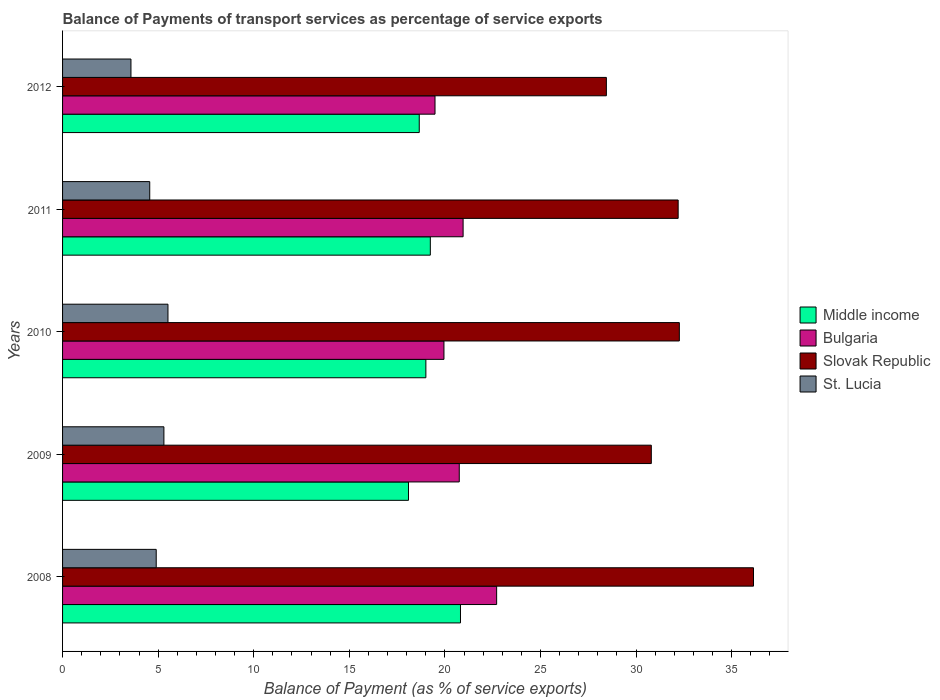How many different coloured bars are there?
Provide a short and direct response. 4. How many bars are there on the 2nd tick from the bottom?
Give a very brief answer. 4. What is the label of the 3rd group of bars from the top?
Your answer should be compact. 2010. What is the balance of payments of transport services in St. Lucia in 2012?
Provide a succinct answer. 3.58. Across all years, what is the maximum balance of payments of transport services in Slovak Republic?
Keep it short and to the point. 36.14. Across all years, what is the minimum balance of payments of transport services in Slovak Republic?
Your response must be concise. 28.45. What is the total balance of payments of transport services in Slovak Republic in the graph?
Your answer should be very brief. 159.86. What is the difference between the balance of payments of transport services in Bulgaria in 2010 and that in 2012?
Make the answer very short. 0.47. What is the difference between the balance of payments of transport services in St. Lucia in 2009 and the balance of payments of transport services in Bulgaria in 2012?
Offer a terse response. -14.18. What is the average balance of payments of transport services in Middle income per year?
Offer a terse response. 19.16. In the year 2010, what is the difference between the balance of payments of transport services in Bulgaria and balance of payments of transport services in Slovak Republic?
Your answer should be very brief. -12.31. In how many years, is the balance of payments of transport services in Middle income greater than 16 %?
Give a very brief answer. 5. What is the ratio of the balance of payments of transport services in Bulgaria in 2010 to that in 2012?
Keep it short and to the point. 1.02. Is the difference between the balance of payments of transport services in Bulgaria in 2009 and 2011 greater than the difference between the balance of payments of transport services in Slovak Republic in 2009 and 2011?
Keep it short and to the point. Yes. What is the difference between the highest and the second highest balance of payments of transport services in Middle income?
Keep it short and to the point. 1.58. What is the difference between the highest and the lowest balance of payments of transport services in Bulgaria?
Offer a terse response. 3.22. In how many years, is the balance of payments of transport services in St. Lucia greater than the average balance of payments of transport services in St. Lucia taken over all years?
Ensure brevity in your answer.  3. What does the 2nd bar from the top in 2012 represents?
Make the answer very short. Slovak Republic. What does the 1st bar from the bottom in 2008 represents?
Give a very brief answer. Middle income. Is it the case that in every year, the sum of the balance of payments of transport services in Bulgaria and balance of payments of transport services in St. Lucia is greater than the balance of payments of transport services in Middle income?
Offer a very short reply. Yes. How many bars are there?
Offer a terse response. 20. Are all the bars in the graph horizontal?
Give a very brief answer. Yes. How many years are there in the graph?
Your answer should be compact. 5. Are the values on the major ticks of X-axis written in scientific E-notation?
Keep it short and to the point. No. Does the graph contain grids?
Make the answer very short. No. Where does the legend appear in the graph?
Your answer should be compact. Center right. How many legend labels are there?
Offer a terse response. 4. What is the title of the graph?
Provide a short and direct response. Balance of Payments of transport services as percentage of service exports. Does "Estonia" appear as one of the legend labels in the graph?
Provide a succinct answer. No. What is the label or title of the X-axis?
Provide a succinct answer. Balance of Payment (as % of service exports). What is the label or title of the Y-axis?
Offer a terse response. Years. What is the Balance of Payment (as % of service exports) in Middle income in 2008?
Provide a short and direct response. 20.82. What is the Balance of Payment (as % of service exports) of Bulgaria in 2008?
Your response must be concise. 22.71. What is the Balance of Payment (as % of service exports) in Slovak Republic in 2008?
Your answer should be very brief. 36.14. What is the Balance of Payment (as % of service exports) in St. Lucia in 2008?
Keep it short and to the point. 4.9. What is the Balance of Payment (as % of service exports) of Middle income in 2009?
Ensure brevity in your answer.  18.1. What is the Balance of Payment (as % of service exports) in Bulgaria in 2009?
Offer a very short reply. 20.75. What is the Balance of Payment (as % of service exports) in Slovak Republic in 2009?
Ensure brevity in your answer.  30.8. What is the Balance of Payment (as % of service exports) in St. Lucia in 2009?
Your answer should be very brief. 5.3. What is the Balance of Payment (as % of service exports) in Middle income in 2010?
Your answer should be compact. 19.01. What is the Balance of Payment (as % of service exports) of Bulgaria in 2010?
Provide a short and direct response. 19.95. What is the Balance of Payment (as % of service exports) of Slovak Republic in 2010?
Provide a succinct answer. 32.27. What is the Balance of Payment (as % of service exports) of St. Lucia in 2010?
Offer a very short reply. 5.51. What is the Balance of Payment (as % of service exports) in Middle income in 2011?
Your response must be concise. 19.24. What is the Balance of Payment (as % of service exports) in Bulgaria in 2011?
Give a very brief answer. 20.95. What is the Balance of Payment (as % of service exports) of Slovak Republic in 2011?
Make the answer very short. 32.2. What is the Balance of Payment (as % of service exports) of St. Lucia in 2011?
Provide a short and direct response. 4.56. What is the Balance of Payment (as % of service exports) in Middle income in 2012?
Offer a very short reply. 18.66. What is the Balance of Payment (as % of service exports) of Bulgaria in 2012?
Keep it short and to the point. 19.48. What is the Balance of Payment (as % of service exports) of Slovak Republic in 2012?
Offer a very short reply. 28.45. What is the Balance of Payment (as % of service exports) in St. Lucia in 2012?
Your answer should be compact. 3.58. Across all years, what is the maximum Balance of Payment (as % of service exports) of Middle income?
Ensure brevity in your answer.  20.82. Across all years, what is the maximum Balance of Payment (as % of service exports) of Bulgaria?
Provide a succinct answer. 22.71. Across all years, what is the maximum Balance of Payment (as % of service exports) of Slovak Republic?
Ensure brevity in your answer.  36.14. Across all years, what is the maximum Balance of Payment (as % of service exports) in St. Lucia?
Offer a terse response. 5.51. Across all years, what is the minimum Balance of Payment (as % of service exports) of Middle income?
Your response must be concise. 18.1. Across all years, what is the minimum Balance of Payment (as % of service exports) of Bulgaria?
Offer a terse response. 19.48. Across all years, what is the minimum Balance of Payment (as % of service exports) of Slovak Republic?
Your answer should be compact. 28.45. Across all years, what is the minimum Balance of Payment (as % of service exports) in St. Lucia?
Provide a succinct answer. 3.58. What is the total Balance of Payment (as % of service exports) of Middle income in the graph?
Provide a succinct answer. 95.81. What is the total Balance of Payment (as % of service exports) in Bulgaria in the graph?
Your response must be concise. 103.85. What is the total Balance of Payment (as % of service exports) in Slovak Republic in the graph?
Your answer should be very brief. 159.86. What is the total Balance of Payment (as % of service exports) in St. Lucia in the graph?
Offer a terse response. 23.85. What is the difference between the Balance of Payment (as % of service exports) of Middle income in 2008 and that in 2009?
Give a very brief answer. 2.72. What is the difference between the Balance of Payment (as % of service exports) of Bulgaria in 2008 and that in 2009?
Your response must be concise. 1.96. What is the difference between the Balance of Payment (as % of service exports) of Slovak Republic in 2008 and that in 2009?
Your answer should be compact. 5.35. What is the difference between the Balance of Payment (as % of service exports) of St. Lucia in 2008 and that in 2009?
Ensure brevity in your answer.  -0.4. What is the difference between the Balance of Payment (as % of service exports) in Middle income in 2008 and that in 2010?
Your answer should be very brief. 1.81. What is the difference between the Balance of Payment (as % of service exports) in Bulgaria in 2008 and that in 2010?
Keep it short and to the point. 2.76. What is the difference between the Balance of Payment (as % of service exports) of Slovak Republic in 2008 and that in 2010?
Give a very brief answer. 3.88. What is the difference between the Balance of Payment (as % of service exports) of St. Lucia in 2008 and that in 2010?
Provide a succinct answer. -0.61. What is the difference between the Balance of Payment (as % of service exports) of Middle income in 2008 and that in 2011?
Provide a succinct answer. 1.58. What is the difference between the Balance of Payment (as % of service exports) of Bulgaria in 2008 and that in 2011?
Provide a short and direct response. 1.75. What is the difference between the Balance of Payment (as % of service exports) of Slovak Republic in 2008 and that in 2011?
Make the answer very short. 3.94. What is the difference between the Balance of Payment (as % of service exports) in St. Lucia in 2008 and that in 2011?
Offer a terse response. 0.34. What is the difference between the Balance of Payment (as % of service exports) of Middle income in 2008 and that in 2012?
Provide a short and direct response. 2.16. What is the difference between the Balance of Payment (as % of service exports) of Bulgaria in 2008 and that in 2012?
Your answer should be very brief. 3.22. What is the difference between the Balance of Payment (as % of service exports) in Slovak Republic in 2008 and that in 2012?
Give a very brief answer. 7.7. What is the difference between the Balance of Payment (as % of service exports) in St. Lucia in 2008 and that in 2012?
Your response must be concise. 1.32. What is the difference between the Balance of Payment (as % of service exports) of Middle income in 2009 and that in 2010?
Offer a terse response. -0.91. What is the difference between the Balance of Payment (as % of service exports) in Bulgaria in 2009 and that in 2010?
Your answer should be compact. 0.8. What is the difference between the Balance of Payment (as % of service exports) in Slovak Republic in 2009 and that in 2010?
Provide a succinct answer. -1.47. What is the difference between the Balance of Payment (as % of service exports) of St. Lucia in 2009 and that in 2010?
Keep it short and to the point. -0.21. What is the difference between the Balance of Payment (as % of service exports) of Middle income in 2009 and that in 2011?
Offer a terse response. -1.14. What is the difference between the Balance of Payment (as % of service exports) in Bulgaria in 2009 and that in 2011?
Offer a terse response. -0.2. What is the difference between the Balance of Payment (as % of service exports) of Slovak Republic in 2009 and that in 2011?
Offer a terse response. -1.4. What is the difference between the Balance of Payment (as % of service exports) of St. Lucia in 2009 and that in 2011?
Keep it short and to the point. 0.74. What is the difference between the Balance of Payment (as % of service exports) in Middle income in 2009 and that in 2012?
Offer a terse response. -0.56. What is the difference between the Balance of Payment (as % of service exports) in Bulgaria in 2009 and that in 2012?
Provide a succinct answer. 1.27. What is the difference between the Balance of Payment (as % of service exports) in Slovak Republic in 2009 and that in 2012?
Offer a very short reply. 2.35. What is the difference between the Balance of Payment (as % of service exports) in St. Lucia in 2009 and that in 2012?
Make the answer very short. 1.72. What is the difference between the Balance of Payment (as % of service exports) in Middle income in 2010 and that in 2011?
Make the answer very short. -0.23. What is the difference between the Balance of Payment (as % of service exports) in Bulgaria in 2010 and that in 2011?
Ensure brevity in your answer.  -1. What is the difference between the Balance of Payment (as % of service exports) of Slovak Republic in 2010 and that in 2011?
Ensure brevity in your answer.  0.06. What is the difference between the Balance of Payment (as % of service exports) in St. Lucia in 2010 and that in 2011?
Offer a terse response. 0.95. What is the difference between the Balance of Payment (as % of service exports) of Middle income in 2010 and that in 2012?
Offer a terse response. 0.35. What is the difference between the Balance of Payment (as % of service exports) of Bulgaria in 2010 and that in 2012?
Give a very brief answer. 0.47. What is the difference between the Balance of Payment (as % of service exports) in Slovak Republic in 2010 and that in 2012?
Keep it short and to the point. 3.82. What is the difference between the Balance of Payment (as % of service exports) of St. Lucia in 2010 and that in 2012?
Your answer should be very brief. 1.94. What is the difference between the Balance of Payment (as % of service exports) in Middle income in 2011 and that in 2012?
Provide a succinct answer. 0.58. What is the difference between the Balance of Payment (as % of service exports) in Bulgaria in 2011 and that in 2012?
Offer a very short reply. 1.47. What is the difference between the Balance of Payment (as % of service exports) of Slovak Republic in 2011 and that in 2012?
Offer a terse response. 3.76. What is the difference between the Balance of Payment (as % of service exports) in St. Lucia in 2011 and that in 2012?
Your answer should be very brief. 0.98. What is the difference between the Balance of Payment (as % of service exports) of Middle income in 2008 and the Balance of Payment (as % of service exports) of Bulgaria in 2009?
Keep it short and to the point. 0.06. What is the difference between the Balance of Payment (as % of service exports) in Middle income in 2008 and the Balance of Payment (as % of service exports) in Slovak Republic in 2009?
Your response must be concise. -9.98. What is the difference between the Balance of Payment (as % of service exports) of Middle income in 2008 and the Balance of Payment (as % of service exports) of St. Lucia in 2009?
Offer a very short reply. 15.51. What is the difference between the Balance of Payment (as % of service exports) in Bulgaria in 2008 and the Balance of Payment (as % of service exports) in Slovak Republic in 2009?
Offer a very short reply. -8.09. What is the difference between the Balance of Payment (as % of service exports) of Bulgaria in 2008 and the Balance of Payment (as % of service exports) of St. Lucia in 2009?
Your response must be concise. 17.41. What is the difference between the Balance of Payment (as % of service exports) in Slovak Republic in 2008 and the Balance of Payment (as % of service exports) in St. Lucia in 2009?
Provide a short and direct response. 30.84. What is the difference between the Balance of Payment (as % of service exports) in Middle income in 2008 and the Balance of Payment (as % of service exports) in Bulgaria in 2010?
Keep it short and to the point. 0.86. What is the difference between the Balance of Payment (as % of service exports) in Middle income in 2008 and the Balance of Payment (as % of service exports) in Slovak Republic in 2010?
Your answer should be compact. -11.45. What is the difference between the Balance of Payment (as % of service exports) of Middle income in 2008 and the Balance of Payment (as % of service exports) of St. Lucia in 2010?
Make the answer very short. 15.3. What is the difference between the Balance of Payment (as % of service exports) in Bulgaria in 2008 and the Balance of Payment (as % of service exports) in Slovak Republic in 2010?
Offer a terse response. -9.56. What is the difference between the Balance of Payment (as % of service exports) of Bulgaria in 2008 and the Balance of Payment (as % of service exports) of St. Lucia in 2010?
Your response must be concise. 17.19. What is the difference between the Balance of Payment (as % of service exports) of Slovak Republic in 2008 and the Balance of Payment (as % of service exports) of St. Lucia in 2010?
Offer a very short reply. 30.63. What is the difference between the Balance of Payment (as % of service exports) in Middle income in 2008 and the Balance of Payment (as % of service exports) in Bulgaria in 2011?
Offer a terse response. -0.14. What is the difference between the Balance of Payment (as % of service exports) in Middle income in 2008 and the Balance of Payment (as % of service exports) in Slovak Republic in 2011?
Provide a short and direct response. -11.39. What is the difference between the Balance of Payment (as % of service exports) of Middle income in 2008 and the Balance of Payment (as % of service exports) of St. Lucia in 2011?
Your answer should be compact. 16.26. What is the difference between the Balance of Payment (as % of service exports) in Bulgaria in 2008 and the Balance of Payment (as % of service exports) in Slovak Republic in 2011?
Your answer should be compact. -9.5. What is the difference between the Balance of Payment (as % of service exports) in Bulgaria in 2008 and the Balance of Payment (as % of service exports) in St. Lucia in 2011?
Make the answer very short. 18.15. What is the difference between the Balance of Payment (as % of service exports) in Slovak Republic in 2008 and the Balance of Payment (as % of service exports) in St. Lucia in 2011?
Keep it short and to the point. 31.58. What is the difference between the Balance of Payment (as % of service exports) of Middle income in 2008 and the Balance of Payment (as % of service exports) of Bulgaria in 2012?
Your answer should be compact. 1.33. What is the difference between the Balance of Payment (as % of service exports) in Middle income in 2008 and the Balance of Payment (as % of service exports) in Slovak Republic in 2012?
Your response must be concise. -7.63. What is the difference between the Balance of Payment (as % of service exports) of Middle income in 2008 and the Balance of Payment (as % of service exports) of St. Lucia in 2012?
Offer a terse response. 17.24. What is the difference between the Balance of Payment (as % of service exports) in Bulgaria in 2008 and the Balance of Payment (as % of service exports) in Slovak Republic in 2012?
Make the answer very short. -5.74. What is the difference between the Balance of Payment (as % of service exports) in Bulgaria in 2008 and the Balance of Payment (as % of service exports) in St. Lucia in 2012?
Give a very brief answer. 19.13. What is the difference between the Balance of Payment (as % of service exports) of Slovak Republic in 2008 and the Balance of Payment (as % of service exports) of St. Lucia in 2012?
Provide a short and direct response. 32.57. What is the difference between the Balance of Payment (as % of service exports) in Middle income in 2009 and the Balance of Payment (as % of service exports) in Bulgaria in 2010?
Give a very brief answer. -1.86. What is the difference between the Balance of Payment (as % of service exports) of Middle income in 2009 and the Balance of Payment (as % of service exports) of Slovak Republic in 2010?
Your answer should be very brief. -14.17. What is the difference between the Balance of Payment (as % of service exports) of Middle income in 2009 and the Balance of Payment (as % of service exports) of St. Lucia in 2010?
Your answer should be compact. 12.58. What is the difference between the Balance of Payment (as % of service exports) of Bulgaria in 2009 and the Balance of Payment (as % of service exports) of Slovak Republic in 2010?
Give a very brief answer. -11.51. What is the difference between the Balance of Payment (as % of service exports) in Bulgaria in 2009 and the Balance of Payment (as % of service exports) in St. Lucia in 2010?
Give a very brief answer. 15.24. What is the difference between the Balance of Payment (as % of service exports) of Slovak Republic in 2009 and the Balance of Payment (as % of service exports) of St. Lucia in 2010?
Keep it short and to the point. 25.29. What is the difference between the Balance of Payment (as % of service exports) in Middle income in 2009 and the Balance of Payment (as % of service exports) in Bulgaria in 2011?
Offer a terse response. -2.86. What is the difference between the Balance of Payment (as % of service exports) of Middle income in 2009 and the Balance of Payment (as % of service exports) of Slovak Republic in 2011?
Your response must be concise. -14.11. What is the difference between the Balance of Payment (as % of service exports) in Middle income in 2009 and the Balance of Payment (as % of service exports) in St. Lucia in 2011?
Make the answer very short. 13.54. What is the difference between the Balance of Payment (as % of service exports) of Bulgaria in 2009 and the Balance of Payment (as % of service exports) of Slovak Republic in 2011?
Your answer should be compact. -11.45. What is the difference between the Balance of Payment (as % of service exports) of Bulgaria in 2009 and the Balance of Payment (as % of service exports) of St. Lucia in 2011?
Your answer should be very brief. 16.19. What is the difference between the Balance of Payment (as % of service exports) in Slovak Republic in 2009 and the Balance of Payment (as % of service exports) in St. Lucia in 2011?
Give a very brief answer. 26.24. What is the difference between the Balance of Payment (as % of service exports) in Middle income in 2009 and the Balance of Payment (as % of service exports) in Bulgaria in 2012?
Your response must be concise. -1.39. What is the difference between the Balance of Payment (as % of service exports) in Middle income in 2009 and the Balance of Payment (as % of service exports) in Slovak Republic in 2012?
Provide a short and direct response. -10.35. What is the difference between the Balance of Payment (as % of service exports) of Middle income in 2009 and the Balance of Payment (as % of service exports) of St. Lucia in 2012?
Offer a very short reply. 14.52. What is the difference between the Balance of Payment (as % of service exports) in Bulgaria in 2009 and the Balance of Payment (as % of service exports) in Slovak Republic in 2012?
Make the answer very short. -7.7. What is the difference between the Balance of Payment (as % of service exports) in Bulgaria in 2009 and the Balance of Payment (as % of service exports) in St. Lucia in 2012?
Offer a very short reply. 17.18. What is the difference between the Balance of Payment (as % of service exports) of Slovak Republic in 2009 and the Balance of Payment (as % of service exports) of St. Lucia in 2012?
Provide a short and direct response. 27.22. What is the difference between the Balance of Payment (as % of service exports) of Middle income in 2010 and the Balance of Payment (as % of service exports) of Bulgaria in 2011?
Offer a very short reply. -1.95. What is the difference between the Balance of Payment (as % of service exports) of Middle income in 2010 and the Balance of Payment (as % of service exports) of Slovak Republic in 2011?
Offer a terse response. -13.2. What is the difference between the Balance of Payment (as % of service exports) in Middle income in 2010 and the Balance of Payment (as % of service exports) in St. Lucia in 2011?
Ensure brevity in your answer.  14.45. What is the difference between the Balance of Payment (as % of service exports) in Bulgaria in 2010 and the Balance of Payment (as % of service exports) in Slovak Republic in 2011?
Keep it short and to the point. -12.25. What is the difference between the Balance of Payment (as % of service exports) of Bulgaria in 2010 and the Balance of Payment (as % of service exports) of St. Lucia in 2011?
Provide a short and direct response. 15.39. What is the difference between the Balance of Payment (as % of service exports) in Slovak Republic in 2010 and the Balance of Payment (as % of service exports) in St. Lucia in 2011?
Provide a short and direct response. 27.7. What is the difference between the Balance of Payment (as % of service exports) in Middle income in 2010 and the Balance of Payment (as % of service exports) in Bulgaria in 2012?
Make the answer very short. -0.48. What is the difference between the Balance of Payment (as % of service exports) of Middle income in 2010 and the Balance of Payment (as % of service exports) of Slovak Republic in 2012?
Keep it short and to the point. -9.44. What is the difference between the Balance of Payment (as % of service exports) in Middle income in 2010 and the Balance of Payment (as % of service exports) in St. Lucia in 2012?
Your response must be concise. 15.43. What is the difference between the Balance of Payment (as % of service exports) of Bulgaria in 2010 and the Balance of Payment (as % of service exports) of Slovak Republic in 2012?
Offer a very short reply. -8.5. What is the difference between the Balance of Payment (as % of service exports) in Bulgaria in 2010 and the Balance of Payment (as % of service exports) in St. Lucia in 2012?
Give a very brief answer. 16.37. What is the difference between the Balance of Payment (as % of service exports) of Slovak Republic in 2010 and the Balance of Payment (as % of service exports) of St. Lucia in 2012?
Offer a very short reply. 28.69. What is the difference between the Balance of Payment (as % of service exports) in Middle income in 2011 and the Balance of Payment (as % of service exports) in Bulgaria in 2012?
Ensure brevity in your answer.  -0.25. What is the difference between the Balance of Payment (as % of service exports) in Middle income in 2011 and the Balance of Payment (as % of service exports) in Slovak Republic in 2012?
Your response must be concise. -9.21. What is the difference between the Balance of Payment (as % of service exports) in Middle income in 2011 and the Balance of Payment (as % of service exports) in St. Lucia in 2012?
Provide a short and direct response. 15.66. What is the difference between the Balance of Payment (as % of service exports) in Bulgaria in 2011 and the Balance of Payment (as % of service exports) in Slovak Republic in 2012?
Give a very brief answer. -7.49. What is the difference between the Balance of Payment (as % of service exports) in Bulgaria in 2011 and the Balance of Payment (as % of service exports) in St. Lucia in 2012?
Your response must be concise. 17.38. What is the difference between the Balance of Payment (as % of service exports) of Slovak Republic in 2011 and the Balance of Payment (as % of service exports) of St. Lucia in 2012?
Offer a very short reply. 28.63. What is the average Balance of Payment (as % of service exports) of Middle income per year?
Make the answer very short. 19.16. What is the average Balance of Payment (as % of service exports) of Bulgaria per year?
Your answer should be compact. 20.77. What is the average Balance of Payment (as % of service exports) of Slovak Republic per year?
Your answer should be compact. 31.97. What is the average Balance of Payment (as % of service exports) in St. Lucia per year?
Give a very brief answer. 4.77. In the year 2008, what is the difference between the Balance of Payment (as % of service exports) of Middle income and Balance of Payment (as % of service exports) of Bulgaria?
Your answer should be very brief. -1.89. In the year 2008, what is the difference between the Balance of Payment (as % of service exports) in Middle income and Balance of Payment (as % of service exports) in Slovak Republic?
Provide a short and direct response. -15.33. In the year 2008, what is the difference between the Balance of Payment (as % of service exports) of Middle income and Balance of Payment (as % of service exports) of St. Lucia?
Provide a short and direct response. 15.92. In the year 2008, what is the difference between the Balance of Payment (as % of service exports) in Bulgaria and Balance of Payment (as % of service exports) in Slovak Republic?
Keep it short and to the point. -13.44. In the year 2008, what is the difference between the Balance of Payment (as % of service exports) in Bulgaria and Balance of Payment (as % of service exports) in St. Lucia?
Your answer should be very brief. 17.81. In the year 2008, what is the difference between the Balance of Payment (as % of service exports) in Slovak Republic and Balance of Payment (as % of service exports) in St. Lucia?
Your response must be concise. 31.25. In the year 2009, what is the difference between the Balance of Payment (as % of service exports) of Middle income and Balance of Payment (as % of service exports) of Bulgaria?
Offer a very short reply. -2.66. In the year 2009, what is the difference between the Balance of Payment (as % of service exports) of Middle income and Balance of Payment (as % of service exports) of Slovak Republic?
Make the answer very short. -12.7. In the year 2009, what is the difference between the Balance of Payment (as % of service exports) of Middle income and Balance of Payment (as % of service exports) of St. Lucia?
Offer a terse response. 12.79. In the year 2009, what is the difference between the Balance of Payment (as % of service exports) of Bulgaria and Balance of Payment (as % of service exports) of Slovak Republic?
Ensure brevity in your answer.  -10.05. In the year 2009, what is the difference between the Balance of Payment (as % of service exports) in Bulgaria and Balance of Payment (as % of service exports) in St. Lucia?
Offer a terse response. 15.45. In the year 2009, what is the difference between the Balance of Payment (as % of service exports) in Slovak Republic and Balance of Payment (as % of service exports) in St. Lucia?
Your response must be concise. 25.5. In the year 2010, what is the difference between the Balance of Payment (as % of service exports) in Middle income and Balance of Payment (as % of service exports) in Bulgaria?
Give a very brief answer. -0.95. In the year 2010, what is the difference between the Balance of Payment (as % of service exports) in Middle income and Balance of Payment (as % of service exports) in Slovak Republic?
Offer a very short reply. -13.26. In the year 2010, what is the difference between the Balance of Payment (as % of service exports) in Middle income and Balance of Payment (as % of service exports) in St. Lucia?
Provide a succinct answer. 13.49. In the year 2010, what is the difference between the Balance of Payment (as % of service exports) in Bulgaria and Balance of Payment (as % of service exports) in Slovak Republic?
Offer a terse response. -12.31. In the year 2010, what is the difference between the Balance of Payment (as % of service exports) of Bulgaria and Balance of Payment (as % of service exports) of St. Lucia?
Provide a short and direct response. 14.44. In the year 2010, what is the difference between the Balance of Payment (as % of service exports) in Slovak Republic and Balance of Payment (as % of service exports) in St. Lucia?
Offer a terse response. 26.75. In the year 2011, what is the difference between the Balance of Payment (as % of service exports) in Middle income and Balance of Payment (as % of service exports) in Bulgaria?
Keep it short and to the point. -1.71. In the year 2011, what is the difference between the Balance of Payment (as % of service exports) in Middle income and Balance of Payment (as % of service exports) in Slovak Republic?
Keep it short and to the point. -12.96. In the year 2011, what is the difference between the Balance of Payment (as % of service exports) of Middle income and Balance of Payment (as % of service exports) of St. Lucia?
Your response must be concise. 14.68. In the year 2011, what is the difference between the Balance of Payment (as % of service exports) of Bulgaria and Balance of Payment (as % of service exports) of Slovak Republic?
Ensure brevity in your answer.  -11.25. In the year 2011, what is the difference between the Balance of Payment (as % of service exports) in Bulgaria and Balance of Payment (as % of service exports) in St. Lucia?
Your response must be concise. 16.39. In the year 2011, what is the difference between the Balance of Payment (as % of service exports) in Slovak Republic and Balance of Payment (as % of service exports) in St. Lucia?
Provide a succinct answer. 27.64. In the year 2012, what is the difference between the Balance of Payment (as % of service exports) of Middle income and Balance of Payment (as % of service exports) of Bulgaria?
Your response must be concise. -0.82. In the year 2012, what is the difference between the Balance of Payment (as % of service exports) of Middle income and Balance of Payment (as % of service exports) of Slovak Republic?
Give a very brief answer. -9.79. In the year 2012, what is the difference between the Balance of Payment (as % of service exports) in Middle income and Balance of Payment (as % of service exports) in St. Lucia?
Make the answer very short. 15.08. In the year 2012, what is the difference between the Balance of Payment (as % of service exports) of Bulgaria and Balance of Payment (as % of service exports) of Slovak Republic?
Provide a short and direct response. -8.96. In the year 2012, what is the difference between the Balance of Payment (as % of service exports) in Bulgaria and Balance of Payment (as % of service exports) in St. Lucia?
Your answer should be compact. 15.91. In the year 2012, what is the difference between the Balance of Payment (as % of service exports) in Slovak Republic and Balance of Payment (as % of service exports) in St. Lucia?
Make the answer very short. 24.87. What is the ratio of the Balance of Payment (as % of service exports) of Middle income in 2008 to that in 2009?
Offer a terse response. 1.15. What is the ratio of the Balance of Payment (as % of service exports) of Bulgaria in 2008 to that in 2009?
Your answer should be compact. 1.09. What is the ratio of the Balance of Payment (as % of service exports) in Slovak Republic in 2008 to that in 2009?
Give a very brief answer. 1.17. What is the ratio of the Balance of Payment (as % of service exports) of St. Lucia in 2008 to that in 2009?
Provide a succinct answer. 0.92. What is the ratio of the Balance of Payment (as % of service exports) in Middle income in 2008 to that in 2010?
Provide a succinct answer. 1.1. What is the ratio of the Balance of Payment (as % of service exports) of Bulgaria in 2008 to that in 2010?
Offer a very short reply. 1.14. What is the ratio of the Balance of Payment (as % of service exports) of Slovak Republic in 2008 to that in 2010?
Provide a succinct answer. 1.12. What is the ratio of the Balance of Payment (as % of service exports) in St. Lucia in 2008 to that in 2010?
Keep it short and to the point. 0.89. What is the ratio of the Balance of Payment (as % of service exports) in Middle income in 2008 to that in 2011?
Provide a succinct answer. 1.08. What is the ratio of the Balance of Payment (as % of service exports) of Bulgaria in 2008 to that in 2011?
Provide a succinct answer. 1.08. What is the ratio of the Balance of Payment (as % of service exports) in Slovak Republic in 2008 to that in 2011?
Provide a short and direct response. 1.12. What is the ratio of the Balance of Payment (as % of service exports) in St. Lucia in 2008 to that in 2011?
Your answer should be compact. 1.07. What is the ratio of the Balance of Payment (as % of service exports) in Middle income in 2008 to that in 2012?
Provide a succinct answer. 1.12. What is the ratio of the Balance of Payment (as % of service exports) of Bulgaria in 2008 to that in 2012?
Your answer should be compact. 1.17. What is the ratio of the Balance of Payment (as % of service exports) in Slovak Republic in 2008 to that in 2012?
Keep it short and to the point. 1.27. What is the ratio of the Balance of Payment (as % of service exports) of St. Lucia in 2008 to that in 2012?
Give a very brief answer. 1.37. What is the ratio of the Balance of Payment (as % of service exports) of Middle income in 2009 to that in 2010?
Keep it short and to the point. 0.95. What is the ratio of the Balance of Payment (as % of service exports) of Bulgaria in 2009 to that in 2010?
Provide a short and direct response. 1.04. What is the ratio of the Balance of Payment (as % of service exports) in Slovak Republic in 2009 to that in 2010?
Keep it short and to the point. 0.95. What is the ratio of the Balance of Payment (as % of service exports) of St. Lucia in 2009 to that in 2010?
Offer a terse response. 0.96. What is the ratio of the Balance of Payment (as % of service exports) of Middle income in 2009 to that in 2011?
Give a very brief answer. 0.94. What is the ratio of the Balance of Payment (as % of service exports) of Bulgaria in 2009 to that in 2011?
Give a very brief answer. 0.99. What is the ratio of the Balance of Payment (as % of service exports) of Slovak Republic in 2009 to that in 2011?
Give a very brief answer. 0.96. What is the ratio of the Balance of Payment (as % of service exports) of St. Lucia in 2009 to that in 2011?
Your answer should be very brief. 1.16. What is the ratio of the Balance of Payment (as % of service exports) of Middle income in 2009 to that in 2012?
Your answer should be very brief. 0.97. What is the ratio of the Balance of Payment (as % of service exports) of Bulgaria in 2009 to that in 2012?
Offer a very short reply. 1.07. What is the ratio of the Balance of Payment (as % of service exports) of Slovak Republic in 2009 to that in 2012?
Offer a very short reply. 1.08. What is the ratio of the Balance of Payment (as % of service exports) in St. Lucia in 2009 to that in 2012?
Make the answer very short. 1.48. What is the ratio of the Balance of Payment (as % of service exports) in Middle income in 2010 to that in 2011?
Offer a very short reply. 0.99. What is the ratio of the Balance of Payment (as % of service exports) in Bulgaria in 2010 to that in 2011?
Offer a very short reply. 0.95. What is the ratio of the Balance of Payment (as % of service exports) of St. Lucia in 2010 to that in 2011?
Keep it short and to the point. 1.21. What is the ratio of the Balance of Payment (as % of service exports) of Middle income in 2010 to that in 2012?
Your response must be concise. 1.02. What is the ratio of the Balance of Payment (as % of service exports) of Slovak Republic in 2010 to that in 2012?
Your answer should be compact. 1.13. What is the ratio of the Balance of Payment (as % of service exports) of St. Lucia in 2010 to that in 2012?
Provide a short and direct response. 1.54. What is the ratio of the Balance of Payment (as % of service exports) of Middle income in 2011 to that in 2012?
Keep it short and to the point. 1.03. What is the ratio of the Balance of Payment (as % of service exports) of Bulgaria in 2011 to that in 2012?
Your answer should be very brief. 1.08. What is the ratio of the Balance of Payment (as % of service exports) in Slovak Republic in 2011 to that in 2012?
Provide a succinct answer. 1.13. What is the ratio of the Balance of Payment (as % of service exports) in St. Lucia in 2011 to that in 2012?
Your answer should be very brief. 1.27. What is the difference between the highest and the second highest Balance of Payment (as % of service exports) of Middle income?
Provide a succinct answer. 1.58. What is the difference between the highest and the second highest Balance of Payment (as % of service exports) in Bulgaria?
Provide a succinct answer. 1.75. What is the difference between the highest and the second highest Balance of Payment (as % of service exports) of Slovak Republic?
Provide a short and direct response. 3.88. What is the difference between the highest and the second highest Balance of Payment (as % of service exports) in St. Lucia?
Offer a terse response. 0.21. What is the difference between the highest and the lowest Balance of Payment (as % of service exports) of Middle income?
Your response must be concise. 2.72. What is the difference between the highest and the lowest Balance of Payment (as % of service exports) of Bulgaria?
Your answer should be compact. 3.22. What is the difference between the highest and the lowest Balance of Payment (as % of service exports) of Slovak Republic?
Your answer should be compact. 7.7. What is the difference between the highest and the lowest Balance of Payment (as % of service exports) in St. Lucia?
Your answer should be very brief. 1.94. 